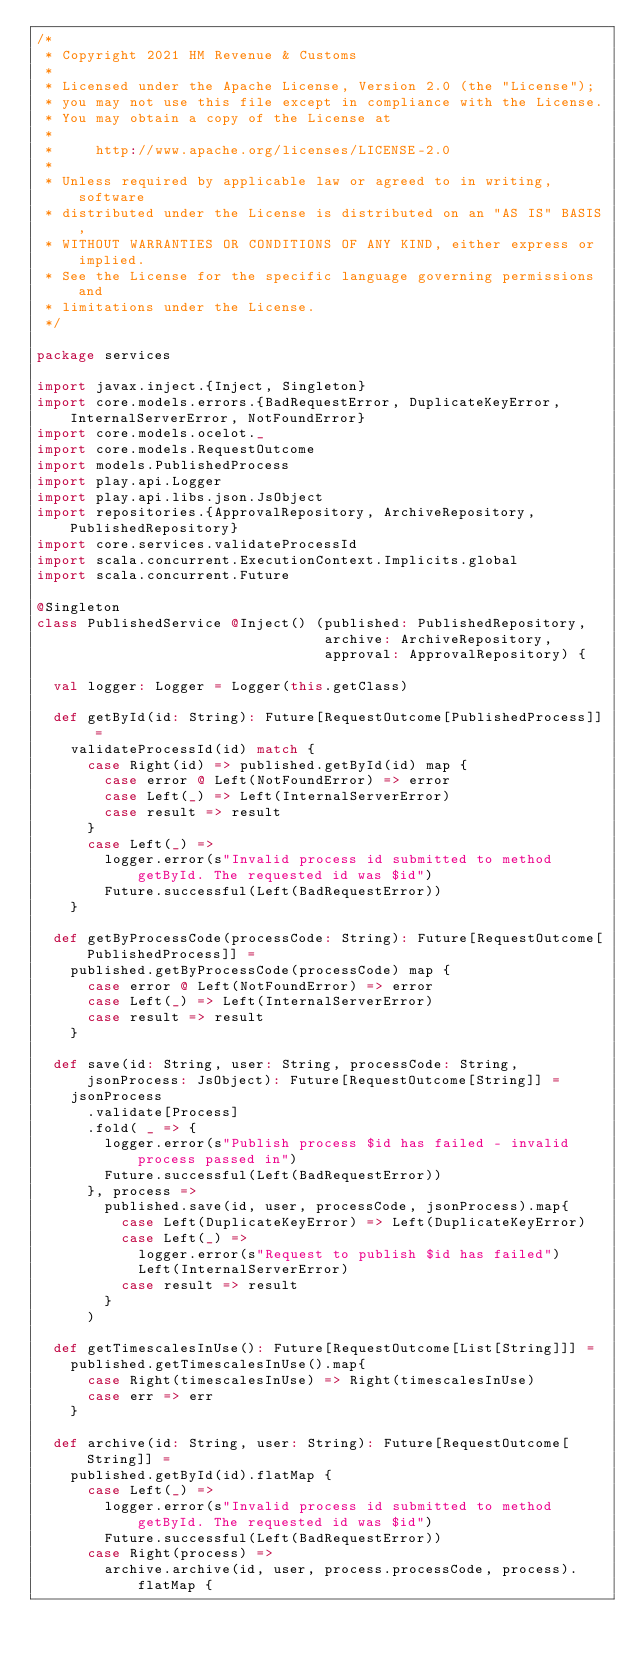<code> <loc_0><loc_0><loc_500><loc_500><_Scala_>/*
 * Copyright 2021 HM Revenue & Customs
 *
 * Licensed under the Apache License, Version 2.0 (the "License");
 * you may not use this file except in compliance with the License.
 * You may obtain a copy of the License at
 *
 *     http://www.apache.org/licenses/LICENSE-2.0
 *
 * Unless required by applicable law or agreed to in writing, software
 * distributed under the License is distributed on an "AS IS" BASIS,
 * WITHOUT WARRANTIES OR CONDITIONS OF ANY KIND, either express or implied.
 * See the License for the specific language governing permissions and
 * limitations under the License.
 */

package services

import javax.inject.{Inject, Singleton}
import core.models.errors.{BadRequestError, DuplicateKeyError, InternalServerError, NotFoundError}
import core.models.ocelot._
import core.models.RequestOutcome
import models.PublishedProcess
import play.api.Logger
import play.api.libs.json.JsObject
import repositories.{ApprovalRepository, ArchiveRepository, PublishedRepository}
import core.services.validateProcessId
import scala.concurrent.ExecutionContext.Implicits.global
import scala.concurrent.Future

@Singleton
class PublishedService @Inject() (published: PublishedRepository,
                                  archive: ArchiveRepository,
                                  approval: ApprovalRepository) {

  val logger: Logger = Logger(this.getClass)

  def getById(id: String): Future[RequestOutcome[PublishedProcess]] =
    validateProcessId(id) match {
      case Right(id) => published.getById(id) map {
        case error @ Left(NotFoundError) => error
        case Left(_) => Left(InternalServerError)
        case result => result
      }
      case Left(_) =>
        logger.error(s"Invalid process id submitted to method getById. The requested id was $id")
        Future.successful(Left(BadRequestError))
    }

  def getByProcessCode(processCode: String): Future[RequestOutcome[PublishedProcess]] =
    published.getByProcessCode(processCode) map {
      case error @ Left(NotFoundError) => error
      case Left(_) => Left(InternalServerError)
      case result => result
    }

  def save(id: String, user: String, processCode: String, jsonProcess: JsObject): Future[RequestOutcome[String]] =
    jsonProcess
      .validate[Process]
      .fold( _ => {
        logger.error(s"Publish process $id has failed - invalid process passed in")
        Future.successful(Left(BadRequestError))
      }, process =>
        published.save(id, user, processCode, jsonProcess).map{
          case Left(DuplicateKeyError) => Left(DuplicateKeyError)
          case Left(_) =>
            logger.error(s"Request to publish $id has failed")
            Left(InternalServerError)
          case result => result
        }
      )

  def getTimescalesInUse(): Future[RequestOutcome[List[String]]] =
    published.getTimescalesInUse().map{
      case Right(timescalesInUse) => Right(timescalesInUse)
      case err => err
    }

  def archive(id: String, user: String): Future[RequestOutcome[String]] =
    published.getById(id).flatMap {
      case Left(_) =>
        logger.error(s"Invalid process id submitted to method getById. The requested id was $id")
        Future.successful(Left(BadRequestError))
      case Right(process) =>
        archive.archive(id, user, process.processCode, process).flatMap {</code> 